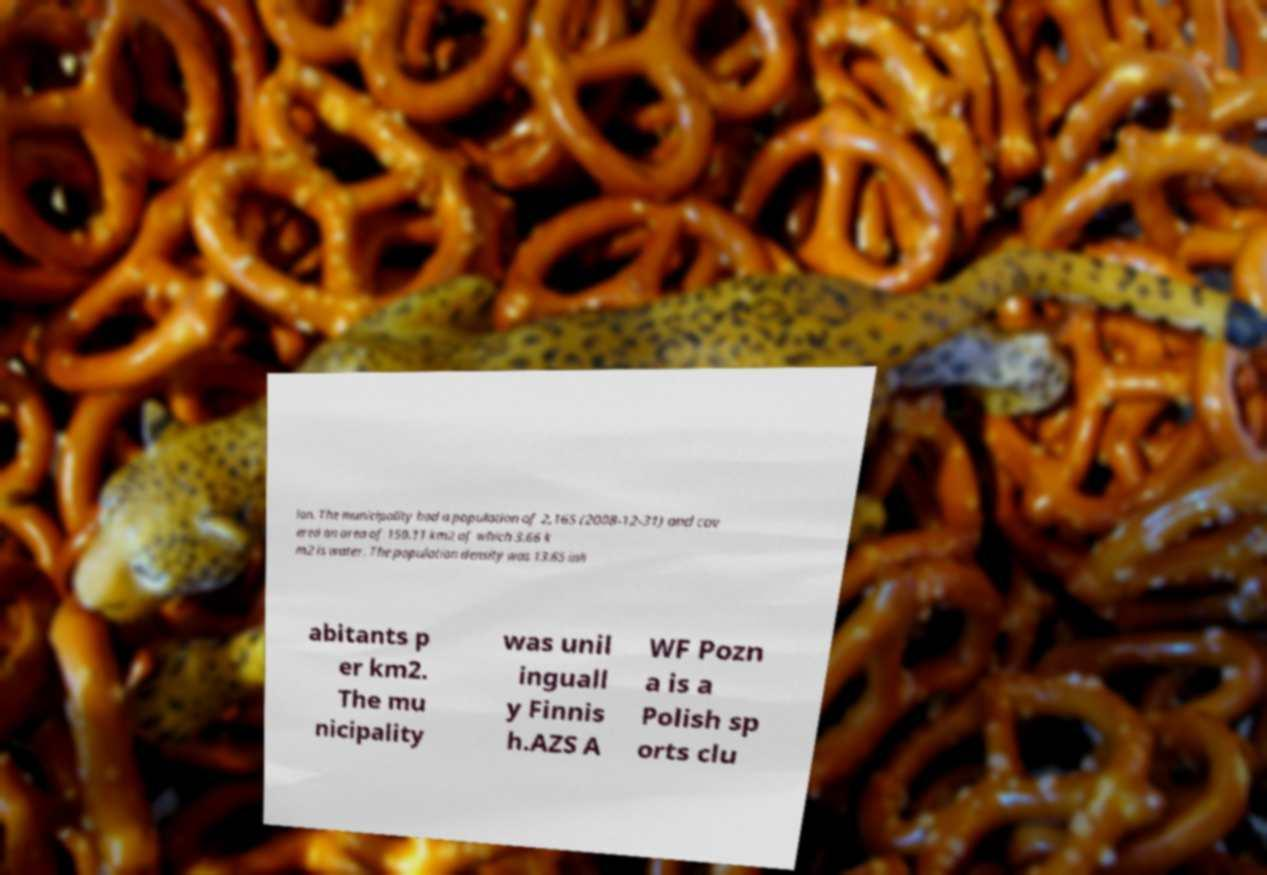Could you assist in decoding the text presented in this image and type it out clearly? ion. The municipality had a population of 2,165 (2008-12-31) and cov ered an area of 150.11 km2 of which 3.66 k m2 is water. The population density was 13.65 inh abitants p er km2. The mu nicipality was unil inguall y Finnis h.AZS A WF Pozn a is a Polish sp orts clu 